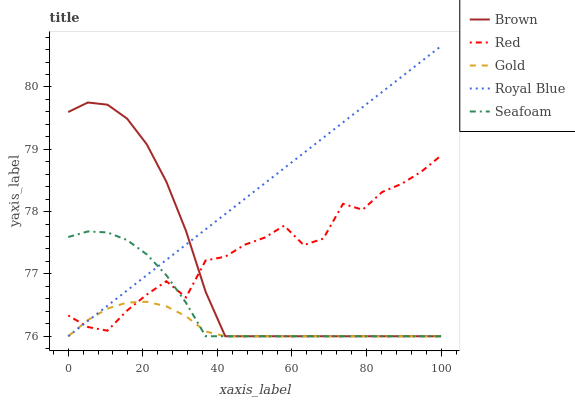Does Gold have the minimum area under the curve?
Answer yes or no. Yes. Does Royal Blue have the maximum area under the curve?
Answer yes or no. Yes. Does Seafoam have the minimum area under the curve?
Answer yes or no. No. Does Seafoam have the maximum area under the curve?
Answer yes or no. No. Is Royal Blue the smoothest?
Answer yes or no. Yes. Is Red the roughest?
Answer yes or no. Yes. Is Seafoam the smoothest?
Answer yes or no. No. Is Seafoam the roughest?
Answer yes or no. No. Does Brown have the lowest value?
Answer yes or no. Yes. Does Red have the lowest value?
Answer yes or no. No. Does Royal Blue have the highest value?
Answer yes or no. Yes. Does Seafoam have the highest value?
Answer yes or no. No. Does Royal Blue intersect Seafoam?
Answer yes or no. Yes. Is Royal Blue less than Seafoam?
Answer yes or no. No. Is Royal Blue greater than Seafoam?
Answer yes or no. No. 